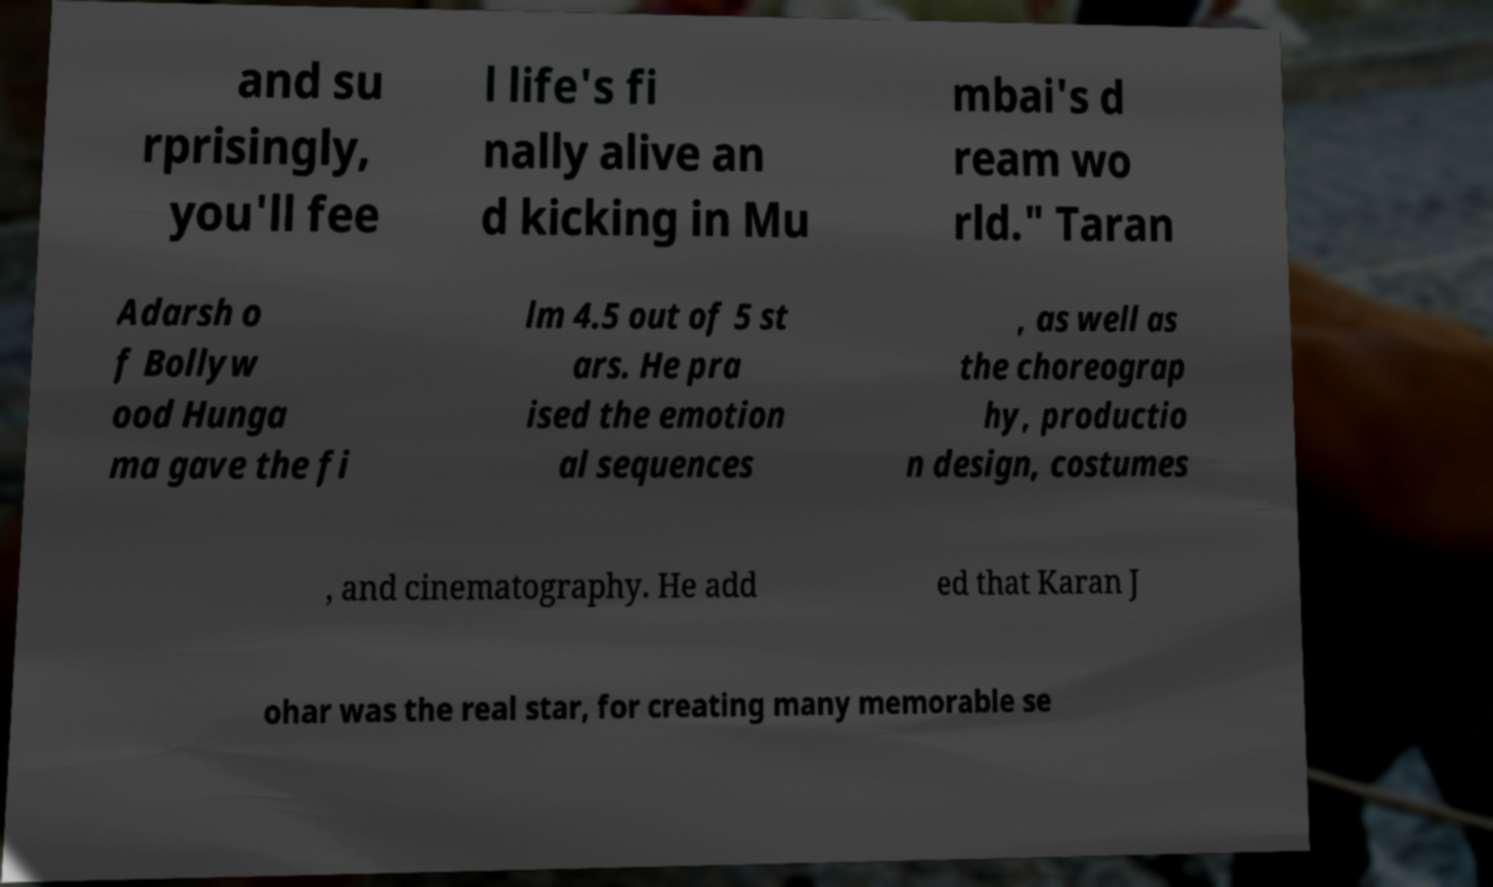For documentation purposes, I need the text within this image transcribed. Could you provide that? and su rprisingly, you'll fee l life's fi nally alive an d kicking in Mu mbai's d ream wo rld." Taran Adarsh o f Bollyw ood Hunga ma gave the fi lm 4.5 out of 5 st ars. He pra ised the emotion al sequences , as well as the choreograp hy, productio n design, costumes , and cinematography. He add ed that Karan J ohar was the real star, for creating many memorable se 